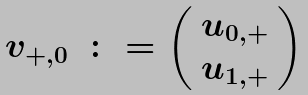Convert formula to latex. <formula><loc_0><loc_0><loc_500><loc_500>\begin{array} { l l } v _ { + , 0 } & \colon = \left ( \begin{array} { l } u _ { 0 , + } \\ u _ { 1 , + } \end{array} \right ) \end{array}</formula> 